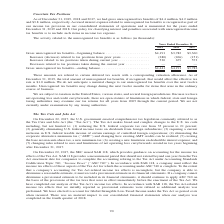According to A10 Networks's financial document, What is the company's unrecognized tax benefit in 2019? According to the financial document, $4,441 (in thousands). The relevant text states: "Gross unrecognized tax benefits—ending balance. . $4,441 $4,191 $3,782..." Also, What is the company's unrecognized tax benefit in 2018? According to the financial document, $4,191 (in thousands). The relevant text states: "ross unrecognized tax benefits—beginning balance . $4,191 $3,782 $3,360 Increases (decrease) related to tax positions from prior years. . (280) (266) (151) In..." Also, What is the company's unrecognized tax benefit in 2017? According to the financial document, $3,782 (in thousands). The relevant text states: "recognized tax benefits—beginning balance . $4,191 $3,782 $3,360 Increases (decrease) related to tax positions from prior years. . (280) (266) (151) Increases..." Also, can you calculate: What is the company's gross unrecognized tax benefits - ending balance in 2016? Based on the calculation: $4,441 + $4,191 + $3,782 , the result is 12414 (in thousands). This is based on the information: "cognized tax benefits—beginning balance . $4,191 $3,782 $3,360 Increases (decrease) related to tax positions from prior years. . (280) (266) (151) Increase ss unrecognized tax benefits—beginning balan..." The key data points involved are: 3,782, 4,191, 4,441. Also, can you calculate: What is the company's change in beginning balance between 2018 and 2019? To answer this question, I need to perform calculations using the financial data. The calculation is: ($4,191 - $3,782)/$3,782 , which equals 10.81 (percentage). This is based on the information: "cognized tax benefits—beginning balance . $4,191 $3,782 $3,360 Increases (decrease) related to tax positions from prior years. . (280) (266) (151) Increase ss unrecognized tax benefits—beginning balan..." The key data points involved are: 3,782, 4,191. Also, can you calculate: What is the total increases related to tax positions taken during current year in 2018 and 2019? Based on the calculation: 530 + 675 , the result is 1205 (in thousands). This is based on the information: "to tax positions taken during current year . 530 675 573 Decreases related to tax positions taken during the current year . — — — ated to tax positions taken during current year . 530 675 573 Decrease..." The key data points involved are: 530, 675. 